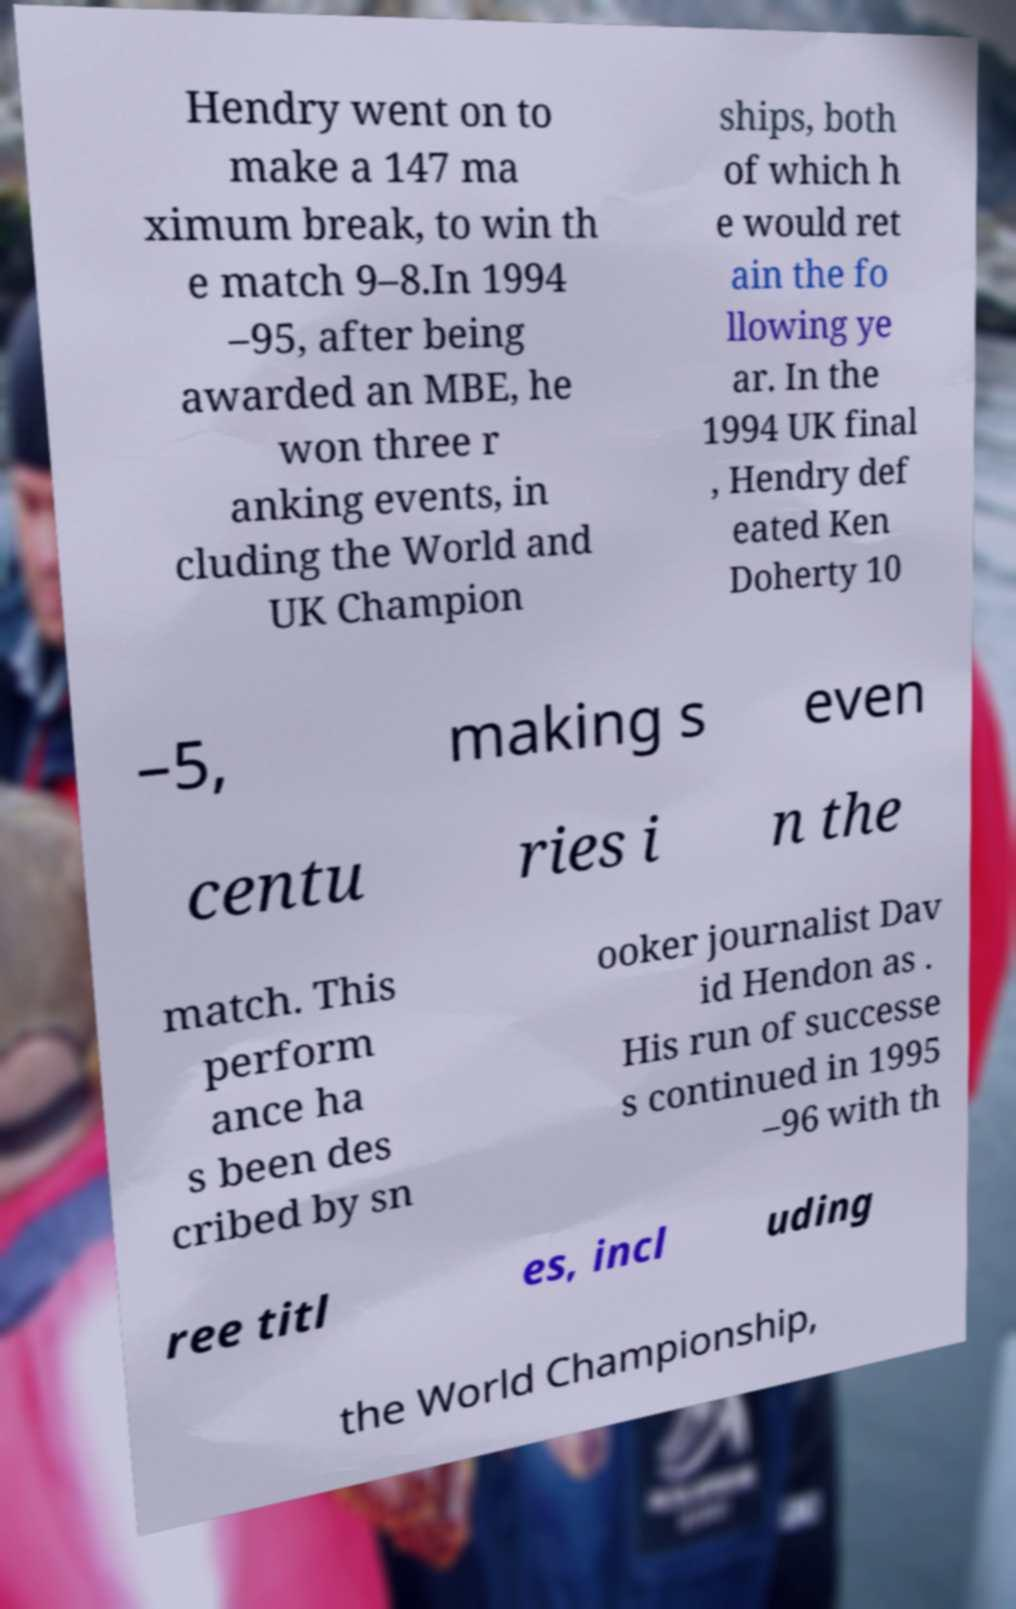Please read and relay the text visible in this image. What does it say? Hendry went on to make a 147 ma ximum break, to win th e match 9–8.In 1994 –95, after being awarded an MBE, he won three r anking events, in cluding the World and UK Champion ships, both of which h e would ret ain the fo llowing ye ar. In the 1994 UK final , Hendry def eated Ken Doherty 10 –5, making s even centu ries i n the match. This perform ance ha s been des cribed by sn ooker journalist Dav id Hendon as . His run of successe s continued in 1995 –96 with th ree titl es, incl uding the World Championship, 